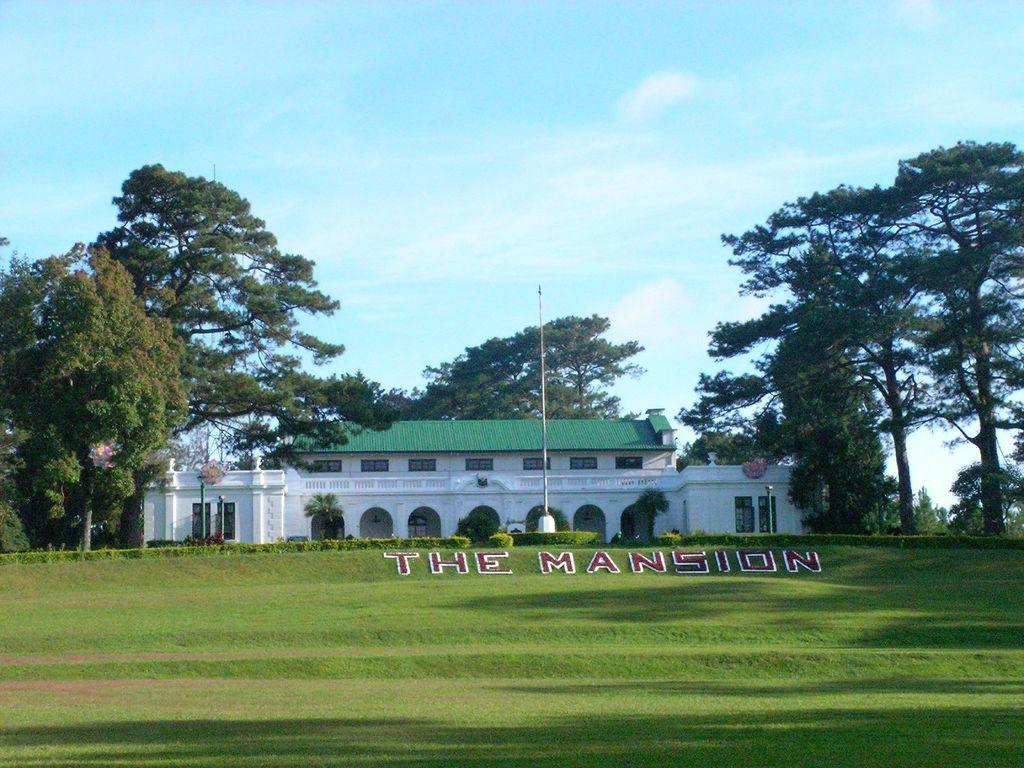What type of vegetation is present in the image? There is grass in the image. What structure can be seen in the image besides the vegetation? There is a pole and a building in the image. What other natural elements are visible in the image? There are trees in the image. Where is the nearest shop located in the image? There is no reference to a shop in the image, so it is not possible to determine its location. What type of bushes can be seen growing in the image? There is no mention of bushes in the image; it features grass, a pole, a building, and trees. 